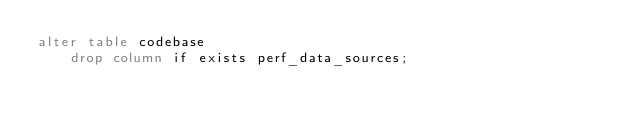Convert code to text. <code><loc_0><loc_0><loc_500><loc_500><_SQL_>alter table codebase
    drop column if exists perf_data_sources;</code> 